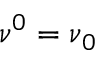<formula> <loc_0><loc_0><loc_500><loc_500>{ \boldsymbol \nu } ^ { 0 } = { \boldsymbol \nu } _ { 0 }</formula> 